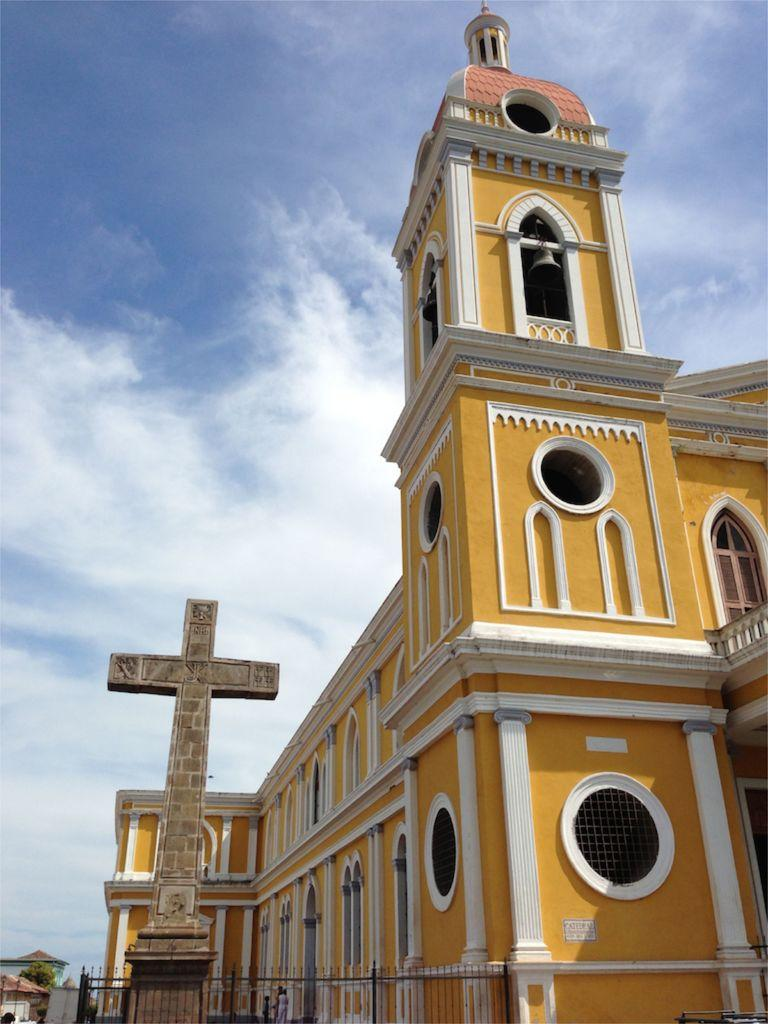What type of building is located in the middle of the image? There is a church in the middle of the image. What is at the bottom of the image? There is an iron grill at the bottom of the image. What is visible at the top of the image? The sky is visible at the top of the image. Can you hear the fairies talking to each other in the image? There are no fairies or talking in the image; it features a church and an iron grill. 